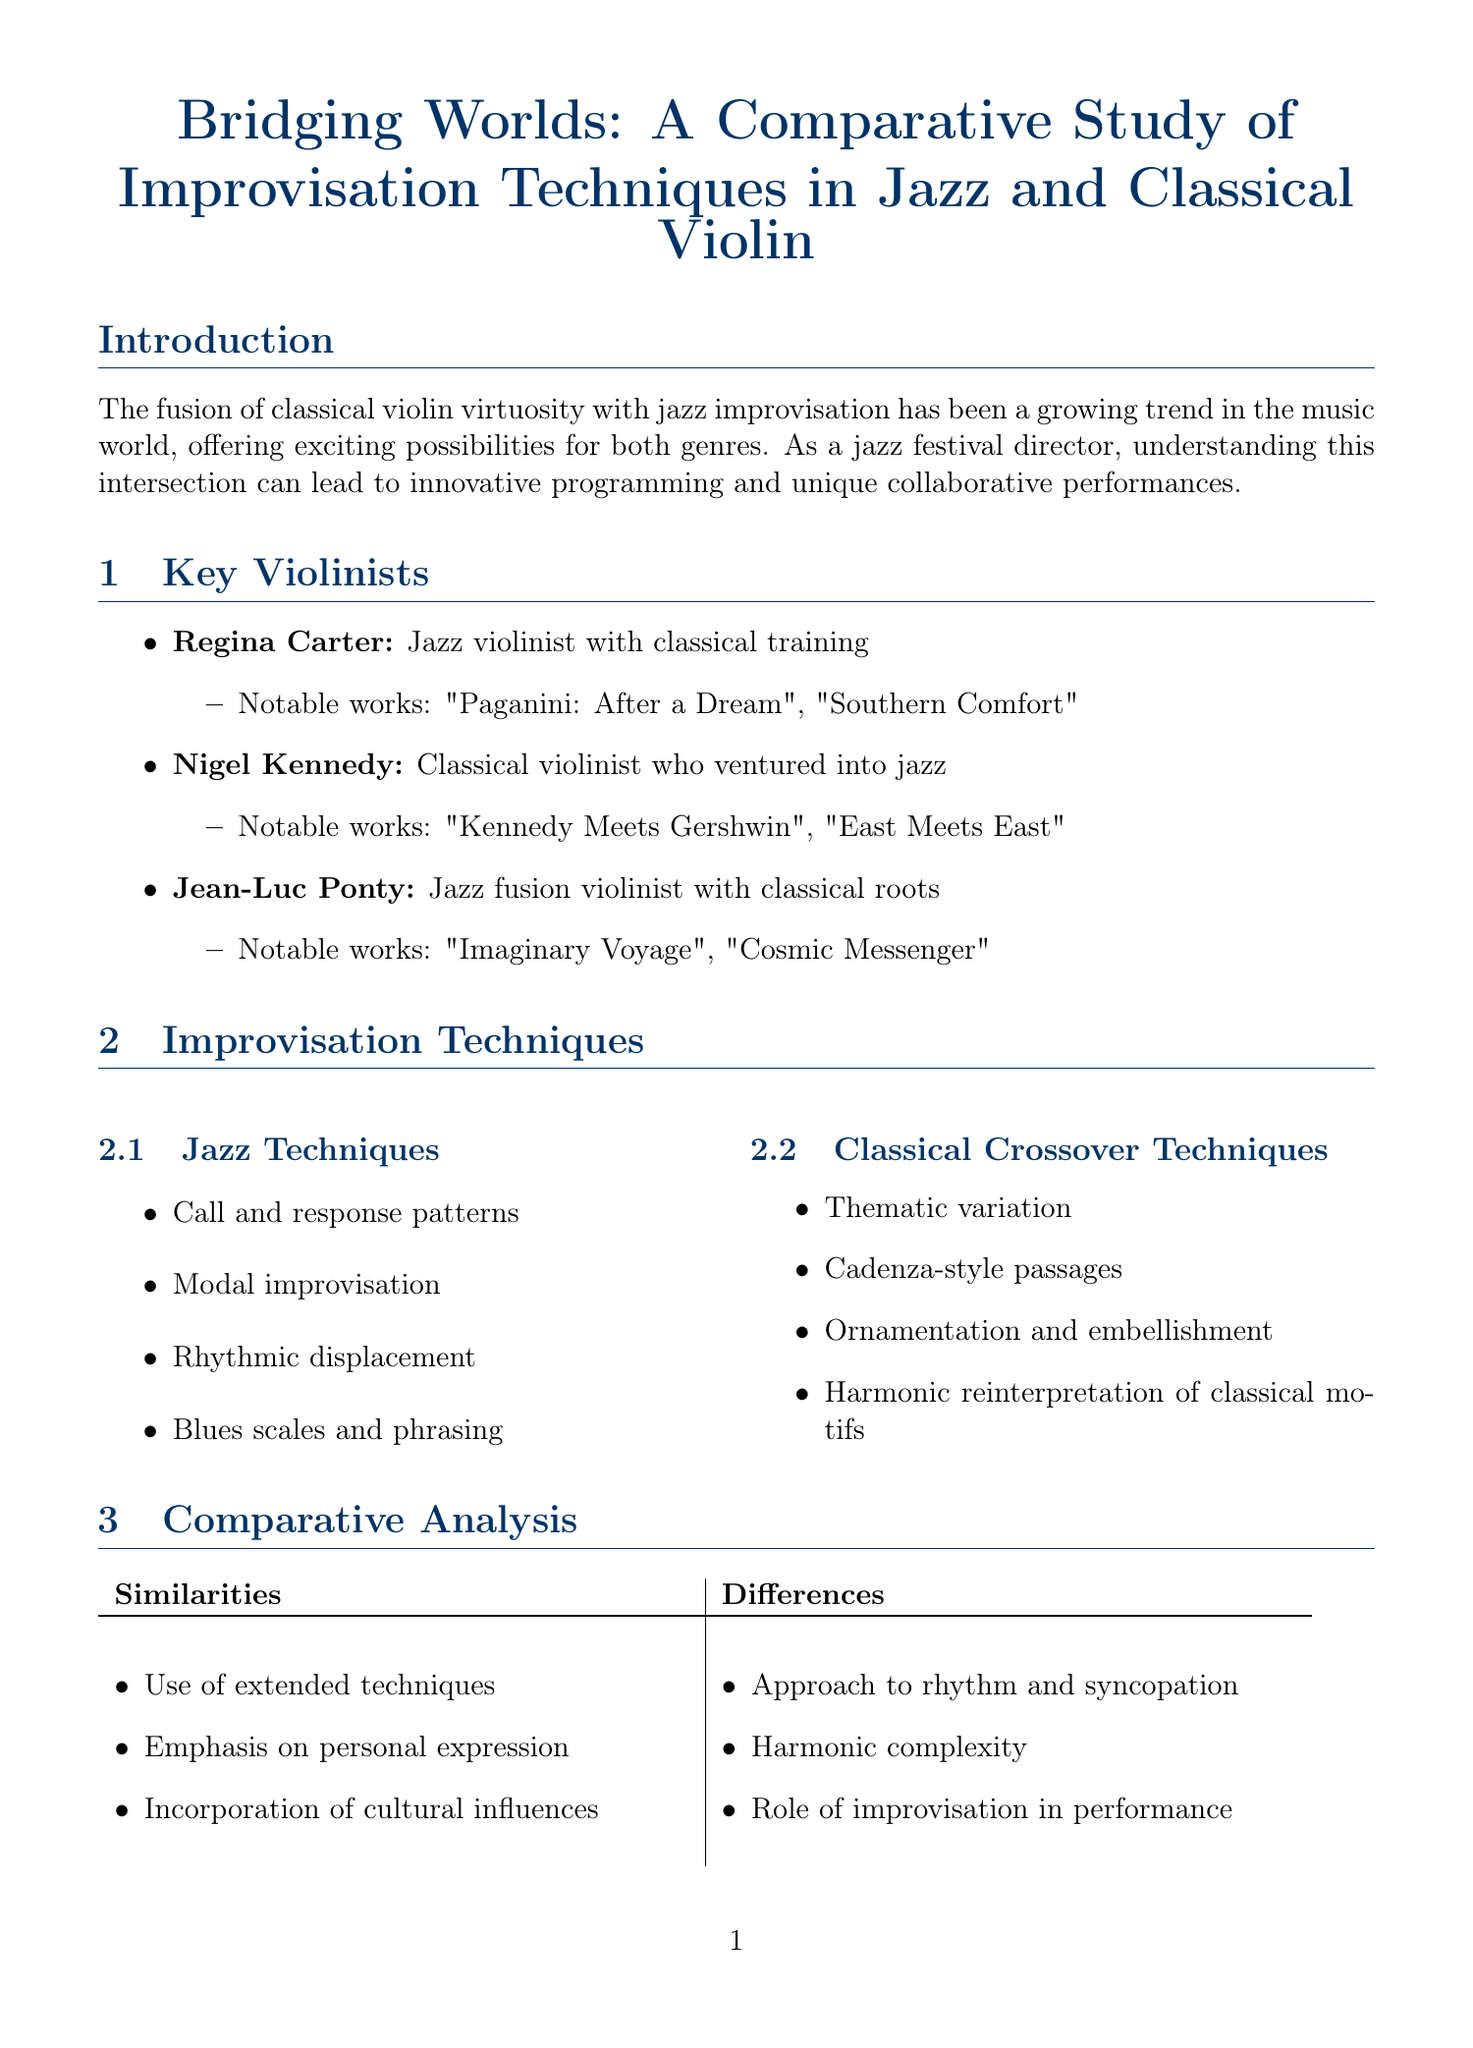What is the title of the report? The title of the report is stated at the beginning of the document.
Answer: Bridging Worlds: A Comparative Study of Improvisation Techniques in Jazz and Classical Violin Who are the key violinists mentioned? The key violinists are listed under the section titled "Key Violinists."
Answer: Regina Carter, Nigel Kennedy, Jean-Luc Ponty What year was "Jazz Violin Studies" published? The document provides publication years for references under the "References" section.
Answer: 2004 What improvisation technique involves the use of cadenza-style passages? This technique is categorized under classical crossover techniques in the document.
Answer: Cadenza-style passages What event featured the Regina Carter and Nigel Kennedy Duo? The case studies provide specific events where performances took place.
Answer: Montreal International Jazz Festival 2019 What is a similarity between jazz and classical improvisation techniques? Similarities are presented in a comparative analysis section of the document.
Answer: Use of extended techniques How many programming opportunities are mentioned? The document lists programming opportunities under the impact on jazz festivals section which can be counted.
Answer: Three What is one way to engage the audience according to the document? Audience engagement strategies are outlined in the impact on jazz festivals section.
Answer: Attracting classical music enthusiasts to jazz performances 